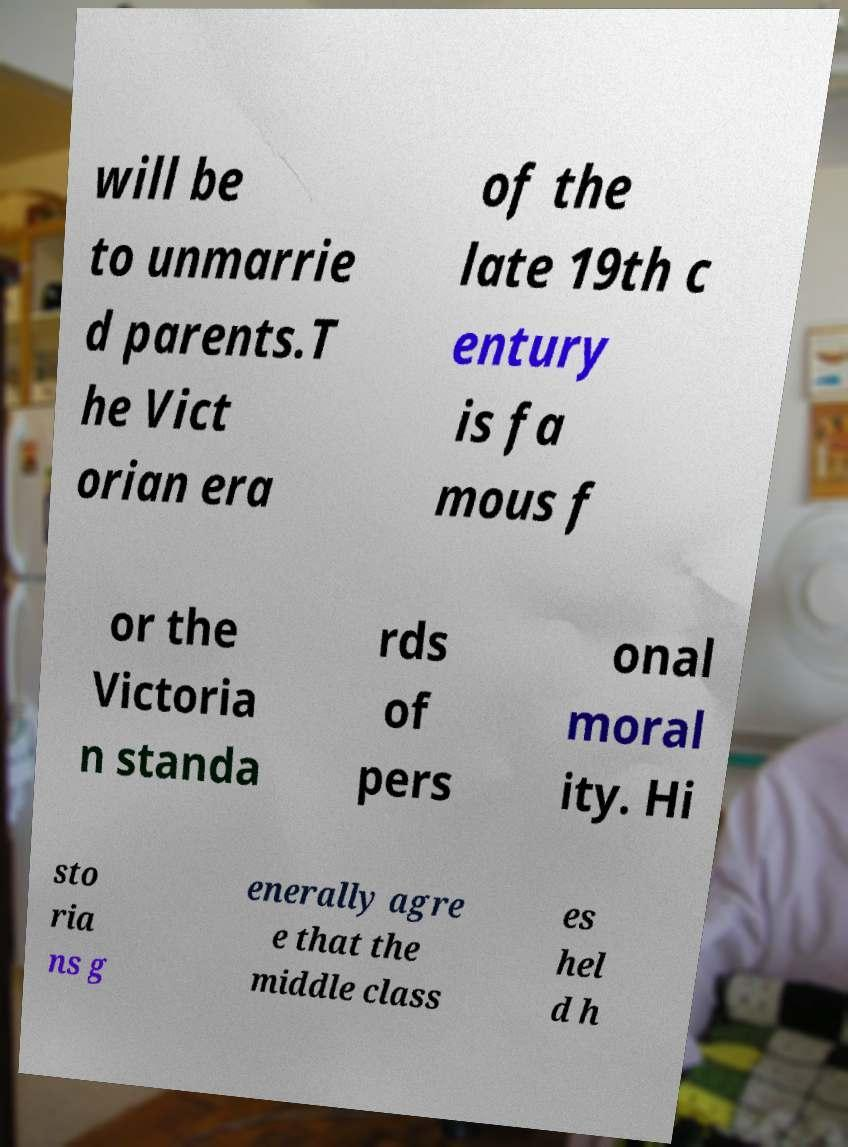Please identify and transcribe the text found in this image. will be to unmarrie d parents.T he Vict orian era of the late 19th c entury is fa mous f or the Victoria n standa rds of pers onal moral ity. Hi sto ria ns g enerally agre e that the middle class es hel d h 